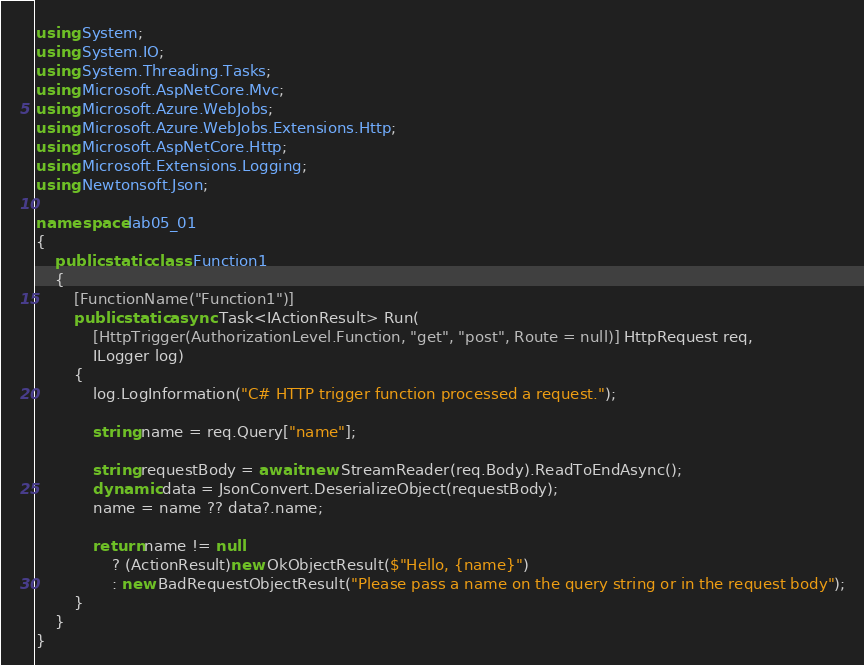<code> <loc_0><loc_0><loc_500><loc_500><_C#_>using System;
using System.IO;
using System.Threading.Tasks;
using Microsoft.AspNetCore.Mvc;
using Microsoft.Azure.WebJobs;
using Microsoft.Azure.WebJobs.Extensions.Http;
using Microsoft.AspNetCore.Http;
using Microsoft.Extensions.Logging;
using Newtonsoft.Json;

namespace lab05_01
{
    public static class Function1
    {
        [FunctionName("Function1")]
        public static async Task<IActionResult> Run(
            [HttpTrigger(AuthorizationLevel.Function, "get", "post", Route = null)] HttpRequest req,
            ILogger log)
        {
            log.LogInformation("C# HTTP trigger function processed a request.");

            string name = req.Query["name"];

            string requestBody = await new StreamReader(req.Body).ReadToEndAsync();
            dynamic data = JsonConvert.DeserializeObject(requestBody);
            name = name ?? data?.name;

            return name != null
                ? (ActionResult)new OkObjectResult($"Hello, {name}")
                : new BadRequestObjectResult("Please pass a name on the query string or in the request body");
        }
    }
}
</code> 